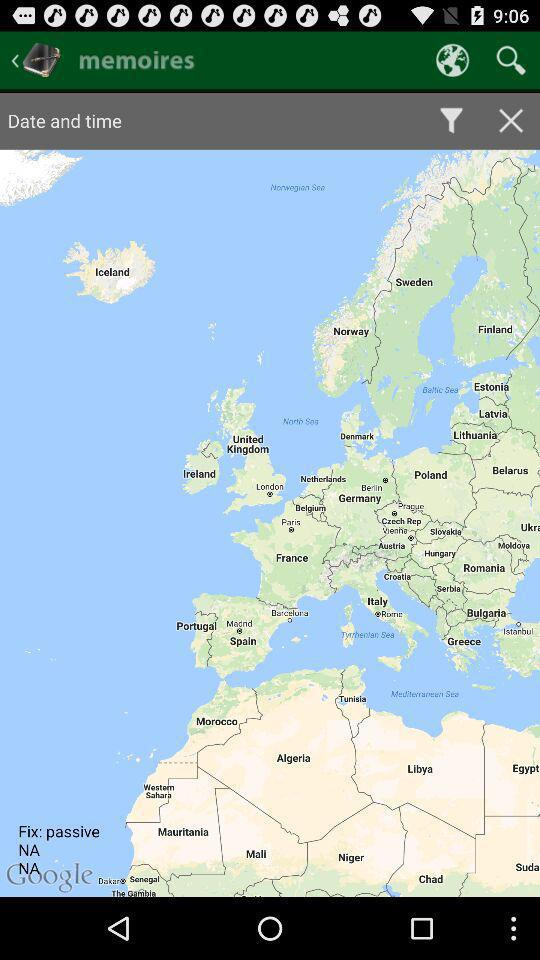What is the name of the application? The name of the application is "memoires". 